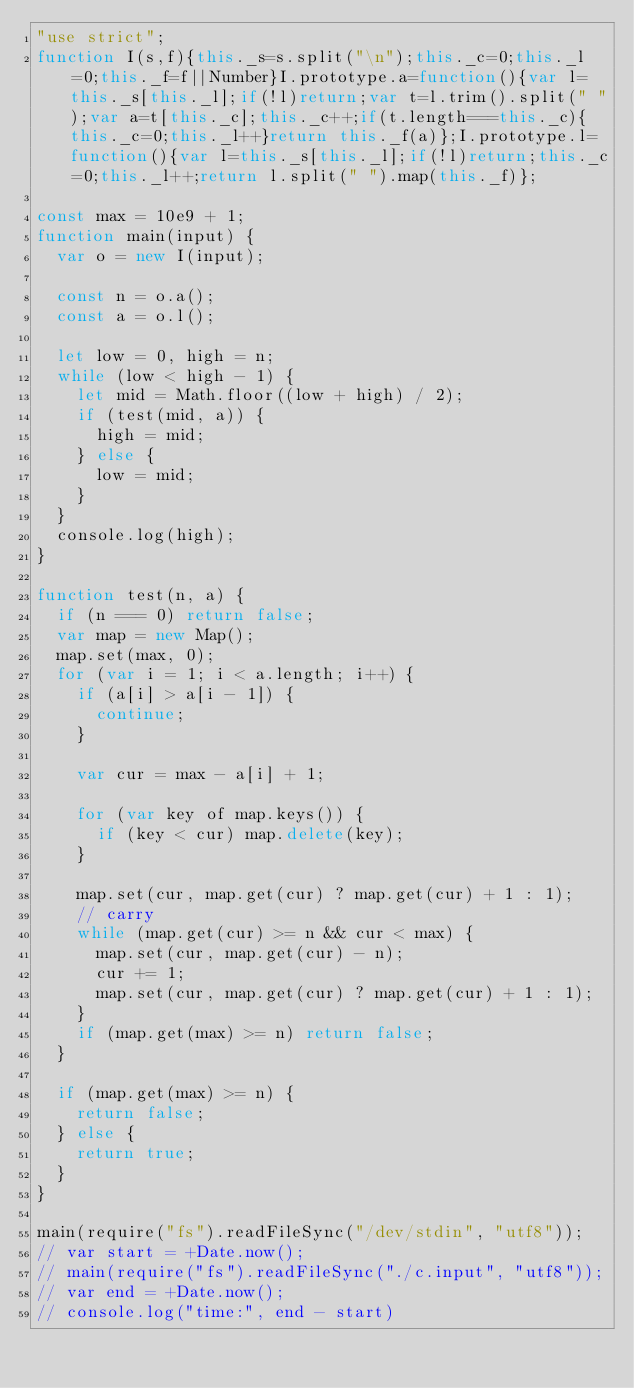Convert code to text. <code><loc_0><loc_0><loc_500><loc_500><_JavaScript_>"use strict";
function I(s,f){this._s=s.split("\n");this._c=0;this._l=0;this._f=f||Number}I.prototype.a=function(){var l=this._s[this._l];if(!l)return;var t=l.trim().split(" ");var a=t[this._c];this._c++;if(t.length===this._c){this._c=0;this._l++}return this._f(a)};I.prototype.l=function(){var l=this._s[this._l];if(!l)return;this._c=0;this._l++;return l.split(" ").map(this._f)};

const max = 10e9 + 1;
function main(input) {
  var o = new I(input);

  const n = o.a();
  const a = o.l();

  let low = 0, high = n;
  while (low < high - 1) {
    let mid = Math.floor((low + high) / 2);
    if (test(mid, a)) {
      high = mid;
    } else {
      low = mid;
    }
  }
  console.log(high);
}

function test(n, a) {
  if (n === 0) return false;
  var map = new Map();
  map.set(max, 0);
  for (var i = 1; i < a.length; i++) {
    if (a[i] > a[i - 1]) {
      continue;
    }

    var cur = max - a[i] + 1;

    for (var key of map.keys()) {
      if (key < cur) map.delete(key);
    }

    map.set(cur, map.get(cur) ? map.get(cur) + 1 : 1);
    // carry
    while (map.get(cur) >= n && cur < max) {
      map.set(cur, map.get(cur) - n);
      cur += 1;
      map.set(cur, map.get(cur) ? map.get(cur) + 1 : 1);
    }
    if (map.get(max) >= n) return false;
  }

  if (map.get(max) >= n) {
    return false;
  } else {
    return true;
  }
}

main(require("fs").readFileSync("/dev/stdin", "utf8"));
// var start = +Date.now();
// main(require("fs").readFileSync("./c.input", "utf8"));
// var end = +Date.now();
// console.log("time:", end - start)</code> 